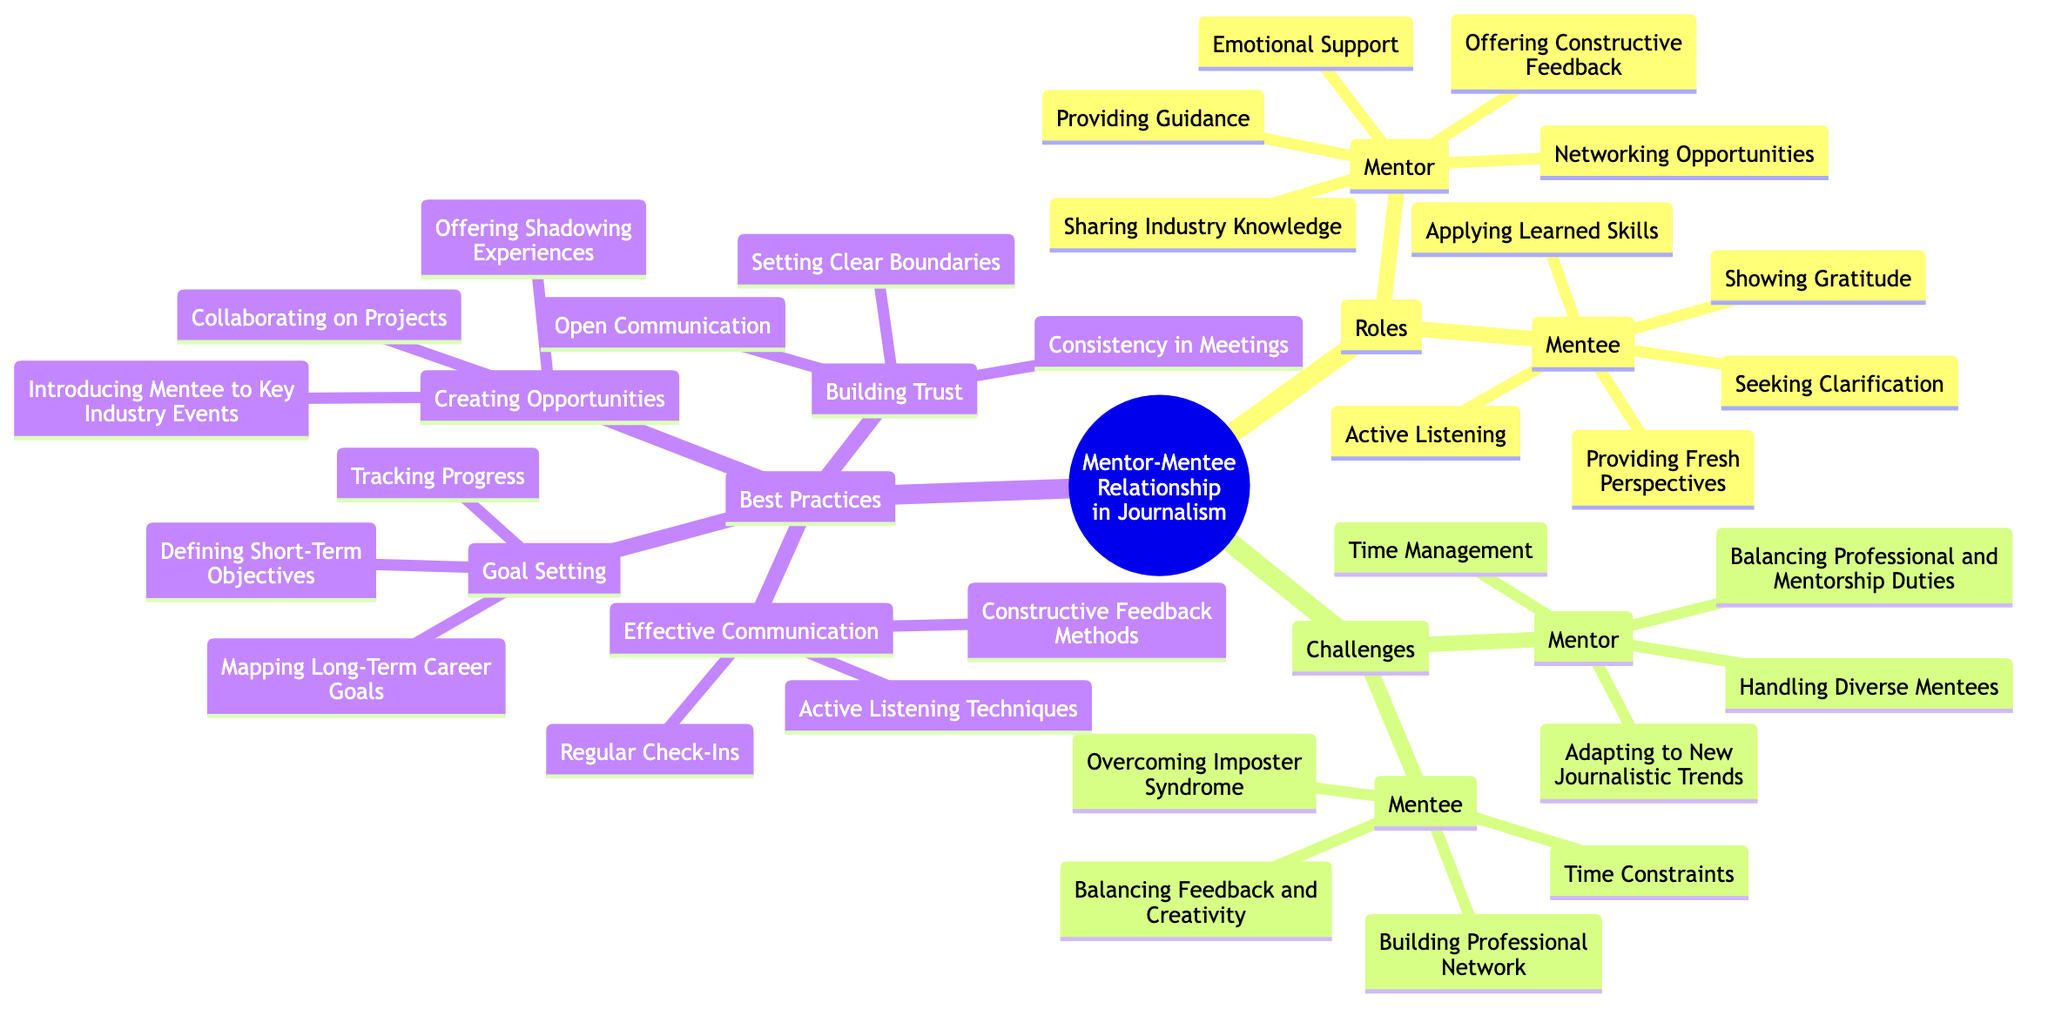What are the roles of the mentor? The roles of the mentor are organized under the "Roles" subtopic. They include providing guidance, sharing industry knowledge, offering constructive feedback, networking opportunities, and emotional support.
Answer: Providing Guidance, Sharing Industry Knowledge, Offering Constructive Feedback, Networking Opportunities, Emotional Support How many challenges are listed for the mentee? The challenges for the mentee are listed under the "Challenges" subtopic. There are four challenges mentioned: overcoming imposter syndrome, balancing feedback and creativity, time constraints, and building a professional network. Thus, the total is four.
Answer: 4 Which subtopic includes "Open Communication"? "Open Communication" is found under the "Building Trust" best practice. It is one of the methods to develop trust in the mentor-mentee relationship.
Answer: Building Trust What is one of the roles of the mentee? The roles of the mentee are found under the "Roles" subtopic. One of them is "Active Listening," which indicates the importance of attentiveness in the relationship.
Answer: Active Listening What is the first challenge listed for the mentor? Under the "Challenges" subtopic, the first challenge listed for the mentor is "Time Management," which highlights a critical aspect of balancing mentorship with professional duties.
Answer: Time Management Which best practice involves tracking progress? "Tracking Progress" is part of the "Goal Setting" best practice, indicating that monitoring achievements is essential in a mentorship context.
Answer: Goal Setting How many roles are listed for the mentee? The role of the mentee includes five distinct points: active listening, seeking clarification, applying learned skills, providing fresh perspectives, and showing gratitude, thus the total count is five.
Answer: 5 What practice suggests introducing mentees to key industry events? The practice of "Creating Opportunities" suggests introducing mentees to key industry events, emphasizing proactive involvement in professional growth.
Answer: Creating Opportunities 